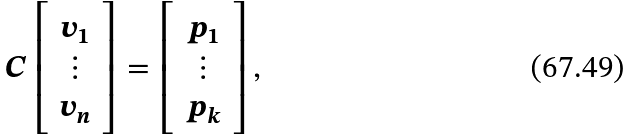<formula> <loc_0><loc_0><loc_500><loc_500>C \left [ \begin{array} { c } v _ { 1 } \\ \vdots \\ v _ { n } \end{array} \right ] = \left [ \begin{array} { c } p _ { 1 } \\ \vdots \\ p _ { k } \end{array} \right ] ,</formula> 